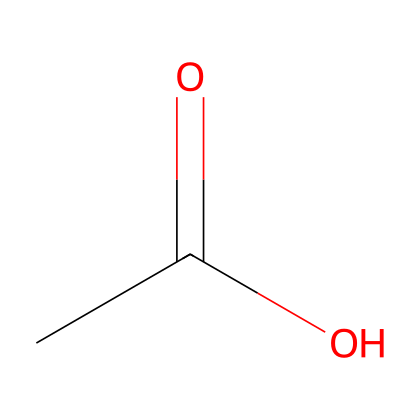What is the name of this chemical? The structure corresponds to acetic acid, which has the functional group of a carboxylic acid. The presence of the carbonyl (C=O) and hydroxyl (–OH) groups identifies it clearly.
Answer: acetic acid How many carbon atoms are present in this chemical? The SMILES notation shows one carbon atom in the structure, while the molecular formula derived indicates that there is only one carbon present.
Answer: 1 What type of chemical bond is present between the carbon and oxygen atoms? In the structure, the bond between carbon and oxygen includes a double bond (C=O) for the carbonyl group and a single bond (C–O) for the hydroxyl group.
Answer: single and double bond What functional group is represented in this chemical? The chemical displays a carboxylic acid functional group, as indicated by the presence of both carbonyl and hydroxyl features in its structure.
Answer: carboxylic acid What is the molecular formula for this chemical? Analyzing the SMILES representation, we can deduce that there is one carbon, two hydrogens, and two oxygens, which leads to the molecular formula C2H4O2.
Answer: C2H4O2 Does this chemical have a strong or weak acidic nature? Acetic acid is known to be a weak acid based on its ability to partially ionize in solution, indicating its acidity level.
Answer: weak 